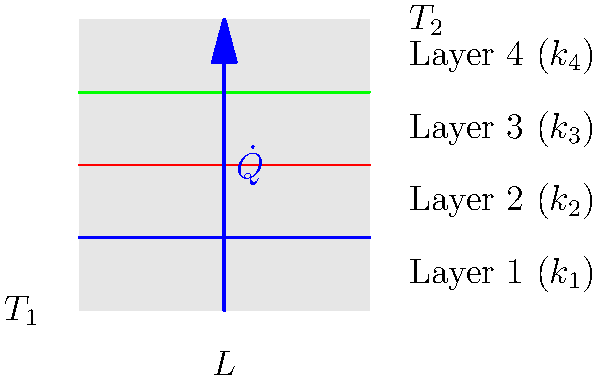Consider a composite material consisting of four layers with thermal conductivities $k_1$, $k_2$, $k_3$, and $k_4$, each with equal thickness $L/4$. The temperature at the left surface is $T_1$, and at the right surface is $T_2$. Derive an expression for the overall thermal resistance of the composite material in terms of the individual layer conductivities and thickness. To solve this problem, we'll follow these steps:

1) Recall that thermal resistance for a single layer is given by:
   $R = \frac{L}{kA}$, where $L$ is thickness, $k$ is thermal conductivity, and $A$ is cross-sectional area.

2) For our composite material, each layer has a thickness of $L/4$. So, the thermal resistance for each layer is:
   $R_1 = \frac{L/4}{k_1A}$, $R_2 = \frac{L/4}{k_2A}$, $R_3 = \frac{L/4}{k_3A}$, $R_4 = \frac{L/4}{k_4A}$

3) In a composite material with layers in series, the total thermal resistance is the sum of individual resistances:
   $R_{total} = R_1 + R_2 + R_3 + R_4$

4) Substituting the expressions from step 2:
   $R_{total} = \frac{L/4}{k_1A} + \frac{L/4}{k_2A} + \frac{L/4}{k_3A} + \frac{L/4}{k_4A}$

5) Factor out the common terms:
   $R_{total} = \frac{L}{4A} (\frac{1}{k_1} + \frac{1}{k_2} + \frac{1}{k_3} + \frac{1}{k_4})$

This is the final expression for the overall thermal resistance of the composite material.
Answer: $R_{total} = \frac{L}{4A} (\frac{1}{k_1} + \frac{1}{k_2} + \frac{1}{k_3} + \frac{1}{k_4})$ 